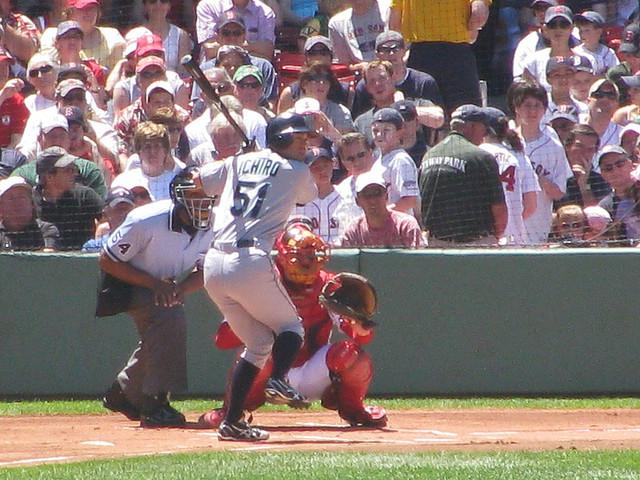What is the net in front of the spectators there for? Please explain your reasoning. stop ball. Without some kind of barrier, such as this net, there's a chance the baseball will be shot into the spectators some kind of way, which can lead to painful injuries. 